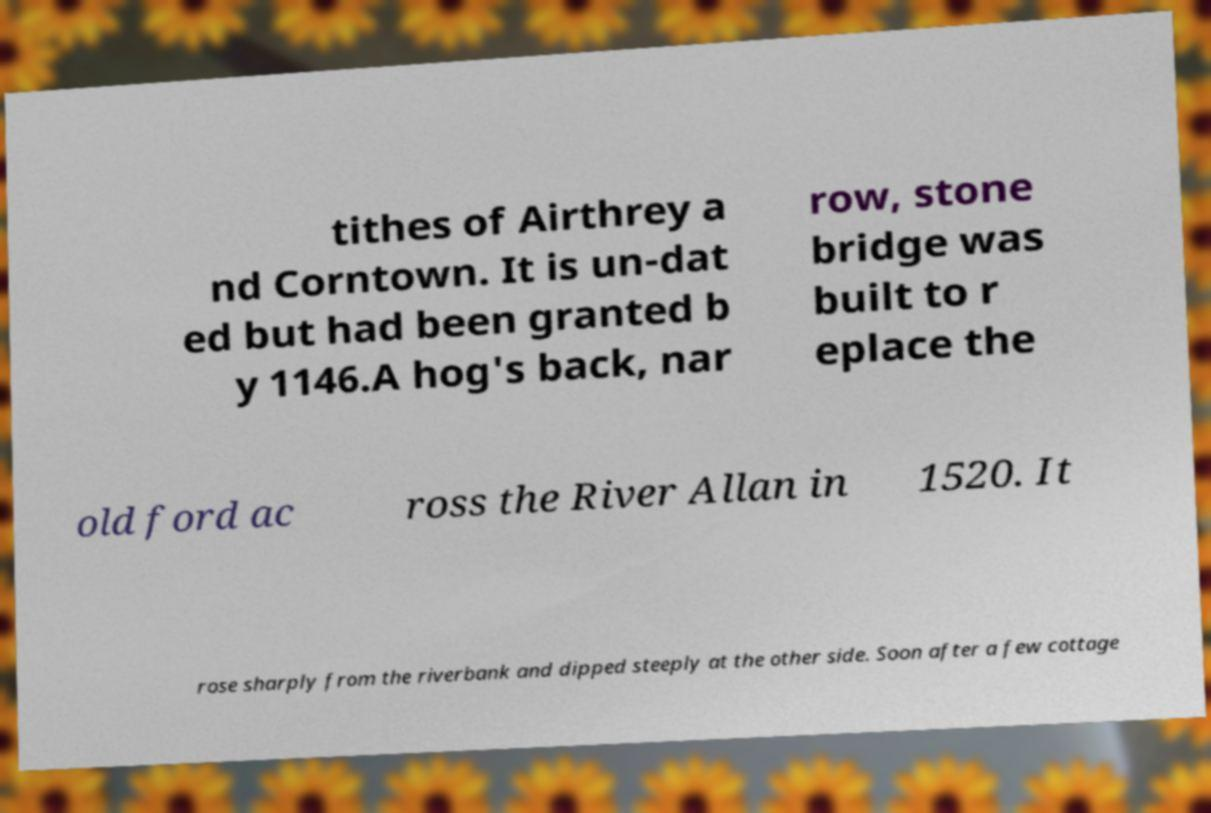Please read and relay the text visible in this image. What does it say? tithes of Airthrey a nd Corntown. It is un-dat ed but had been granted b y 1146.A hog's back, nar row, stone bridge was built to r eplace the old ford ac ross the River Allan in 1520. It rose sharply from the riverbank and dipped steeply at the other side. Soon after a few cottage 